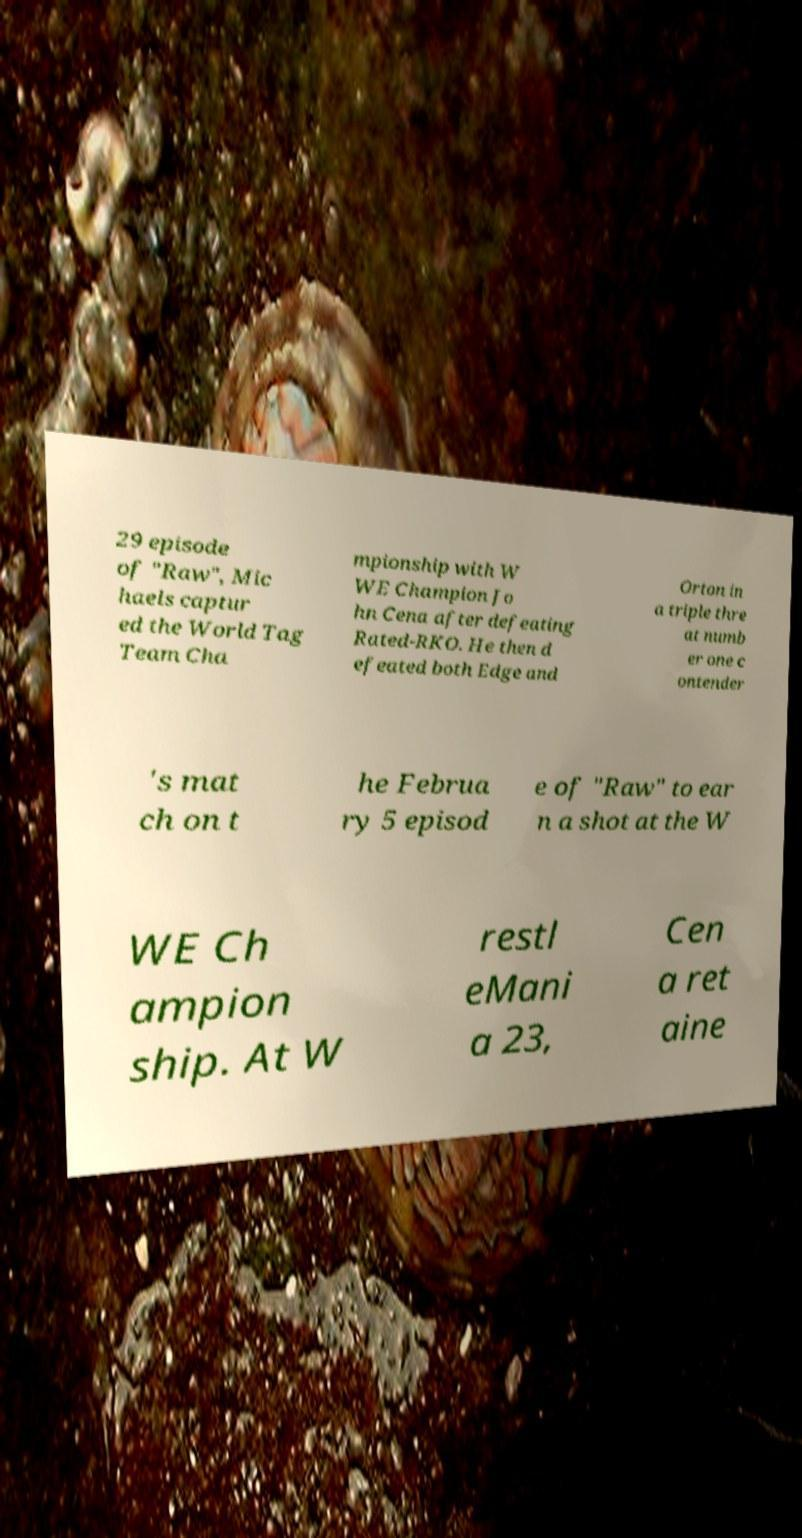Could you assist in decoding the text presented in this image and type it out clearly? 29 episode of "Raw", Mic haels captur ed the World Tag Team Cha mpionship with W WE Champion Jo hn Cena after defeating Rated-RKO. He then d efeated both Edge and Orton in a triple thre at numb er one c ontender 's mat ch on t he Februa ry 5 episod e of "Raw" to ear n a shot at the W WE Ch ampion ship. At W restl eMani a 23, Cen a ret aine 